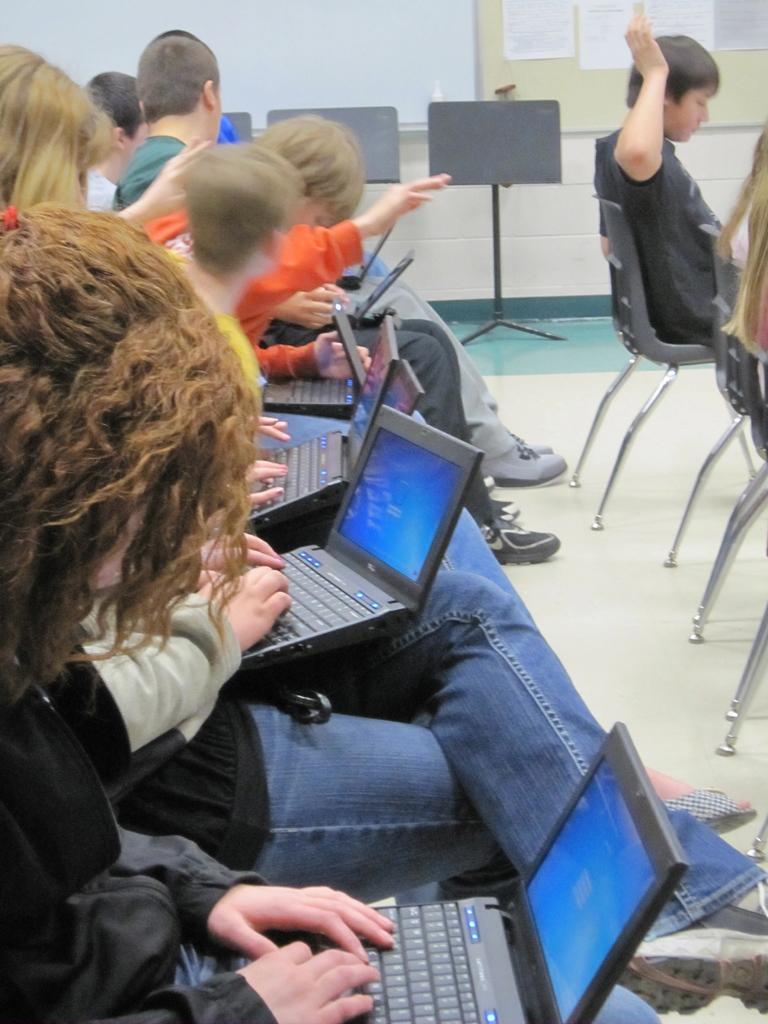Describe this image in one or two sentences. In this image we can see some persons who are sitting on chairs operating laptops keeping on their laps and at the background of the image there are some boards and some papers attached to the board. 